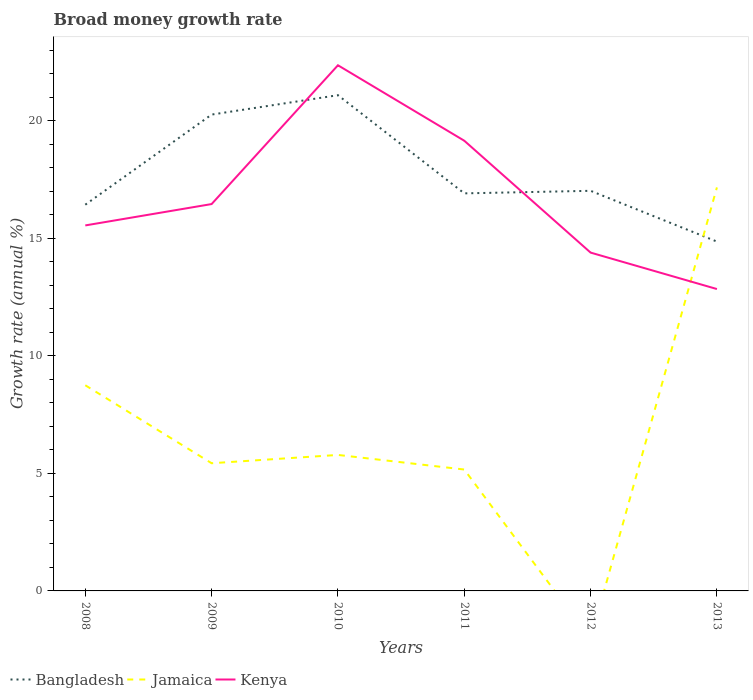Does the line corresponding to Kenya intersect with the line corresponding to Jamaica?
Keep it short and to the point. Yes. Is the number of lines equal to the number of legend labels?
Ensure brevity in your answer.  No. Across all years, what is the maximum growth rate in Bangladesh?
Make the answer very short. 14.86. What is the total growth rate in Kenya in the graph?
Keep it short and to the point. 6.31. What is the difference between the highest and the second highest growth rate in Jamaica?
Give a very brief answer. 17.17. What is the difference between the highest and the lowest growth rate in Kenya?
Provide a short and direct response. 2. Is the growth rate in Kenya strictly greater than the growth rate in Jamaica over the years?
Give a very brief answer. No. How many lines are there?
Offer a very short reply. 3. How many years are there in the graph?
Your answer should be very brief. 6. What is the difference between two consecutive major ticks on the Y-axis?
Your answer should be compact. 5. Does the graph contain grids?
Keep it short and to the point. No. How many legend labels are there?
Ensure brevity in your answer.  3. How are the legend labels stacked?
Offer a terse response. Horizontal. What is the title of the graph?
Offer a terse response. Broad money growth rate. What is the label or title of the X-axis?
Offer a terse response. Years. What is the label or title of the Y-axis?
Provide a short and direct response. Growth rate (annual %). What is the Growth rate (annual %) in Bangladesh in 2008?
Provide a short and direct response. 16.43. What is the Growth rate (annual %) of Jamaica in 2008?
Offer a very short reply. 8.75. What is the Growth rate (annual %) in Kenya in 2008?
Make the answer very short. 15.55. What is the Growth rate (annual %) of Bangladesh in 2009?
Ensure brevity in your answer.  20.26. What is the Growth rate (annual %) of Jamaica in 2009?
Your answer should be very brief. 5.43. What is the Growth rate (annual %) in Kenya in 2009?
Ensure brevity in your answer.  16.46. What is the Growth rate (annual %) in Bangladesh in 2010?
Offer a terse response. 21.09. What is the Growth rate (annual %) in Jamaica in 2010?
Offer a terse response. 5.79. What is the Growth rate (annual %) of Kenya in 2010?
Make the answer very short. 22.36. What is the Growth rate (annual %) in Bangladesh in 2011?
Your answer should be compact. 16.91. What is the Growth rate (annual %) of Jamaica in 2011?
Keep it short and to the point. 5.16. What is the Growth rate (annual %) in Kenya in 2011?
Offer a very short reply. 19.15. What is the Growth rate (annual %) in Bangladesh in 2012?
Offer a terse response. 17.02. What is the Growth rate (annual %) in Kenya in 2012?
Give a very brief answer. 14.39. What is the Growth rate (annual %) of Bangladesh in 2013?
Ensure brevity in your answer.  14.86. What is the Growth rate (annual %) of Jamaica in 2013?
Offer a terse response. 17.17. What is the Growth rate (annual %) in Kenya in 2013?
Your response must be concise. 12.84. Across all years, what is the maximum Growth rate (annual %) in Bangladesh?
Ensure brevity in your answer.  21.09. Across all years, what is the maximum Growth rate (annual %) of Jamaica?
Offer a very short reply. 17.17. Across all years, what is the maximum Growth rate (annual %) in Kenya?
Ensure brevity in your answer.  22.36. Across all years, what is the minimum Growth rate (annual %) of Bangladesh?
Provide a succinct answer. 14.86. Across all years, what is the minimum Growth rate (annual %) of Kenya?
Ensure brevity in your answer.  12.84. What is the total Growth rate (annual %) in Bangladesh in the graph?
Make the answer very short. 106.58. What is the total Growth rate (annual %) in Jamaica in the graph?
Your answer should be compact. 42.3. What is the total Growth rate (annual %) in Kenya in the graph?
Provide a succinct answer. 100.75. What is the difference between the Growth rate (annual %) of Bangladesh in 2008 and that in 2009?
Keep it short and to the point. -3.83. What is the difference between the Growth rate (annual %) of Jamaica in 2008 and that in 2009?
Your answer should be compact. 3.32. What is the difference between the Growth rate (annual %) in Kenya in 2008 and that in 2009?
Your response must be concise. -0.91. What is the difference between the Growth rate (annual %) in Bangladesh in 2008 and that in 2010?
Give a very brief answer. -4.66. What is the difference between the Growth rate (annual %) of Jamaica in 2008 and that in 2010?
Provide a short and direct response. 2.96. What is the difference between the Growth rate (annual %) in Kenya in 2008 and that in 2010?
Keep it short and to the point. -6.81. What is the difference between the Growth rate (annual %) in Bangladesh in 2008 and that in 2011?
Provide a succinct answer. -0.48. What is the difference between the Growth rate (annual %) in Jamaica in 2008 and that in 2011?
Ensure brevity in your answer.  3.58. What is the difference between the Growth rate (annual %) of Kenya in 2008 and that in 2011?
Your answer should be compact. -3.6. What is the difference between the Growth rate (annual %) of Bangladesh in 2008 and that in 2012?
Give a very brief answer. -0.59. What is the difference between the Growth rate (annual %) of Kenya in 2008 and that in 2012?
Your answer should be very brief. 1.16. What is the difference between the Growth rate (annual %) in Bangladesh in 2008 and that in 2013?
Provide a short and direct response. 1.57. What is the difference between the Growth rate (annual %) in Jamaica in 2008 and that in 2013?
Your answer should be compact. -8.42. What is the difference between the Growth rate (annual %) of Kenya in 2008 and that in 2013?
Provide a succinct answer. 2.71. What is the difference between the Growth rate (annual %) in Bangladesh in 2009 and that in 2010?
Your response must be concise. -0.82. What is the difference between the Growth rate (annual %) of Jamaica in 2009 and that in 2010?
Ensure brevity in your answer.  -0.35. What is the difference between the Growth rate (annual %) in Kenya in 2009 and that in 2010?
Ensure brevity in your answer.  -5.9. What is the difference between the Growth rate (annual %) in Bangladesh in 2009 and that in 2011?
Make the answer very short. 3.35. What is the difference between the Growth rate (annual %) in Jamaica in 2009 and that in 2011?
Keep it short and to the point. 0.27. What is the difference between the Growth rate (annual %) in Kenya in 2009 and that in 2011?
Make the answer very short. -2.69. What is the difference between the Growth rate (annual %) in Bangladesh in 2009 and that in 2012?
Your answer should be compact. 3.24. What is the difference between the Growth rate (annual %) in Kenya in 2009 and that in 2012?
Make the answer very short. 2.06. What is the difference between the Growth rate (annual %) of Bangladesh in 2009 and that in 2013?
Give a very brief answer. 5.4. What is the difference between the Growth rate (annual %) of Jamaica in 2009 and that in 2013?
Provide a short and direct response. -11.73. What is the difference between the Growth rate (annual %) in Kenya in 2009 and that in 2013?
Keep it short and to the point. 3.62. What is the difference between the Growth rate (annual %) in Bangladesh in 2010 and that in 2011?
Keep it short and to the point. 4.18. What is the difference between the Growth rate (annual %) of Jamaica in 2010 and that in 2011?
Give a very brief answer. 0.62. What is the difference between the Growth rate (annual %) of Kenya in 2010 and that in 2011?
Make the answer very short. 3.21. What is the difference between the Growth rate (annual %) in Bangladesh in 2010 and that in 2012?
Provide a short and direct response. 4.07. What is the difference between the Growth rate (annual %) in Kenya in 2010 and that in 2012?
Offer a terse response. 7.97. What is the difference between the Growth rate (annual %) of Bangladesh in 2010 and that in 2013?
Your response must be concise. 6.23. What is the difference between the Growth rate (annual %) in Jamaica in 2010 and that in 2013?
Ensure brevity in your answer.  -11.38. What is the difference between the Growth rate (annual %) in Kenya in 2010 and that in 2013?
Ensure brevity in your answer.  9.52. What is the difference between the Growth rate (annual %) of Bangladesh in 2011 and that in 2012?
Offer a very short reply. -0.11. What is the difference between the Growth rate (annual %) in Kenya in 2011 and that in 2012?
Keep it short and to the point. 4.76. What is the difference between the Growth rate (annual %) in Bangladesh in 2011 and that in 2013?
Make the answer very short. 2.05. What is the difference between the Growth rate (annual %) in Jamaica in 2011 and that in 2013?
Give a very brief answer. -12. What is the difference between the Growth rate (annual %) in Kenya in 2011 and that in 2013?
Make the answer very short. 6.31. What is the difference between the Growth rate (annual %) of Bangladesh in 2012 and that in 2013?
Ensure brevity in your answer.  2.16. What is the difference between the Growth rate (annual %) in Kenya in 2012 and that in 2013?
Keep it short and to the point. 1.55. What is the difference between the Growth rate (annual %) in Bangladesh in 2008 and the Growth rate (annual %) in Jamaica in 2009?
Keep it short and to the point. 11. What is the difference between the Growth rate (annual %) in Bangladesh in 2008 and the Growth rate (annual %) in Kenya in 2009?
Your answer should be compact. -0.03. What is the difference between the Growth rate (annual %) of Jamaica in 2008 and the Growth rate (annual %) of Kenya in 2009?
Ensure brevity in your answer.  -7.71. What is the difference between the Growth rate (annual %) of Bangladesh in 2008 and the Growth rate (annual %) of Jamaica in 2010?
Ensure brevity in your answer.  10.65. What is the difference between the Growth rate (annual %) in Bangladesh in 2008 and the Growth rate (annual %) in Kenya in 2010?
Ensure brevity in your answer.  -5.93. What is the difference between the Growth rate (annual %) of Jamaica in 2008 and the Growth rate (annual %) of Kenya in 2010?
Offer a terse response. -13.61. What is the difference between the Growth rate (annual %) in Bangladesh in 2008 and the Growth rate (annual %) in Jamaica in 2011?
Your answer should be compact. 11.27. What is the difference between the Growth rate (annual %) in Bangladesh in 2008 and the Growth rate (annual %) in Kenya in 2011?
Your answer should be very brief. -2.72. What is the difference between the Growth rate (annual %) in Jamaica in 2008 and the Growth rate (annual %) in Kenya in 2011?
Your response must be concise. -10.4. What is the difference between the Growth rate (annual %) of Bangladesh in 2008 and the Growth rate (annual %) of Kenya in 2012?
Offer a very short reply. 2.04. What is the difference between the Growth rate (annual %) of Jamaica in 2008 and the Growth rate (annual %) of Kenya in 2012?
Your answer should be compact. -5.64. What is the difference between the Growth rate (annual %) of Bangladesh in 2008 and the Growth rate (annual %) of Jamaica in 2013?
Provide a succinct answer. -0.73. What is the difference between the Growth rate (annual %) in Bangladesh in 2008 and the Growth rate (annual %) in Kenya in 2013?
Your answer should be compact. 3.59. What is the difference between the Growth rate (annual %) in Jamaica in 2008 and the Growth rate (annual %) in Kenya in 2013?
Make the answer very short. -4.09. What is the difference between the Growth rate (annual %) in Bangladesh in 2009 and the Growth rate (annual %) in Jamaica in 2010?
Your response must be concise. 14.48. What is the difference between the Growth rate (annual %) in Bangladesh in 2009 and the Growth rate (annual %) in Kenya in 2010?
Your answer should be very brief. -2.1. What is the difference between the Growth rate (annual %) of Jamaica in 2009 and the Growth rate (annual %) of Kenya in 2010?
Offer a very short reply. -16.93. What is the difference between the Growth rate (annual %) in Bangladesh in 2009 and the Growth rate (annual %) in Jamaica in 2011?
Make the answer very short. 15.1. What is the difference between the Growth rate (annual %) of Bangladesh in 2009 and the Growth rate (annual %) of Kenya in 2011?
Ensure brevity in your answer.  1.11. What is the difference between the Growth rate (annual %) in Jamaica in 2009 and the Growth rate (annual %) in Kenya in 2011?
Provide a succinct answer. -13.72. What is the difference between the Growth rate (annual %) of Bangladesh in 2009 and the Growth rate (annual %) of Kenya in 2012?
Give a very brief answer. 5.87. What is the difference between the Growth rate (annual %) of Jamaica in 2009 and the Growth rate (annual %) of Kenya in 2012?
Give a very brief answer. -8.96. What is the difference between the Growth rate (annual %) in Bangladesh in 2009 and the Growth rate (annual %) in Jamaica in 2013?
Provide a short and direct response. 3.1. What is the difference between the Growth rate (annual %) in Bangladesh in 2009 and the Growth rate (annual %) in Kenya in 2013?
Ensure brevity in your answer.  7.42. What is the difference between the Growth rate (annual %) of Jamaica in 2009 and the Growth rate (annual %) of Kenya in 2013?
Give a very brief answer. -7.41. What is the difference between the Growth rate (annual %) of Bangladesh in 2010 and the Growth rate (annual %) of Jamaica in 2011?
Your answer should be very brief. 15.92. What is the difference between the Growth rate (annual %) in Bangladesh in 2010 and the Growth rate (annual %) in Kenya in 2011?
Provide a succinct answer. 1.94. What is the difference between the Growth rate (annual %) of Jamaica in 2010 and the Growth rate (annual %) of Kenya in 2011?
Your answer should be compact. -13.37. What is the difference between the Growth rate (annual %) in Bangladesh in 2010 and the Growth rate (annual %) in Kenya in 2012?
Offer a very short reply. 6.7. What is the difference between the Growth rate (annual %) in Jamaica in 2010 and the Growth rate (annual %) in Kenya in 2012?
Offer a very short reply. -8.61. What is the difference between the Growth rate (annual %) in Bangladesh in 2010 and the Growth rate (annual %) in Jamaica in 2013?
Provide a short and direct response. 3.92. What is the difference between the Growth rate (annual %) of Bangladesh in 2010 and the Growth rate (annual %) of Kenya in 2013?
Make the answer very short. 8.25. What is the difference between the Growth rate (annual %) of Jamaica in 2010 and the Growth rate (annual %) of Kenya in 2013?
Your answer should be compact. -7.06. What is the difference between the Growth rate (annual %) in Bangladesh in 2011 and the Growth rate (annual %) in Kenya in 2012?
Your answer should be compact. 2.52. What is the difference between the Growth rate (annual %) of Jamaica in 2011 and the Growth rate (annual %) of Kenya in 2012?
Ensure brevity in your answer.  -9.23. What is the difference between the Growth rate (annual %) in Bangladesh in 2011 and the Growth rate (annual %) in Jamaica in 2013?
Keep it short and to the point. -0.25. What is the difference between the Growth rate (annual %) of Bangladesh in 2011 and the Growth rate (annual %) of Kenya in 2013?
Offer a terse response. 4.07. What is the difference between the Growth rate (annual %) of Jamaica in 2011 and the Growth rate (annual %) of Kenya in 2013?
Your answer should be compact. -7.68. What is the difference between the Growth rate (annual %) in Bangladesh in 2012 and the Growth rate (annual %) in Jamaica in 2013?
Your answer should be compact. -0.14. What is the difference between the Growth rate (annual %) of Bangladesh in 2012 and the Growth rate (annual %) of Kenya in 2013?
Offer a terse response. 4.18. What is the average Growth rate (annual %) of Bangladesh per year?
Offer a terse response. 17.76. What is the average Growth rate (annual %) in Jamaica per year?
Give a very brief answer. 7.05. What is the average Growth rate (annual %) in Kenya per year?
Give a very brief answer. 16.79. In the year 2008, what is the difference between the Growth rate (annual %) in Bangladesh and Growth rate (annual %) in Jamaica?
Give a very brief answer. 7.68. In the year 2008, what is the difference between the Growth rate (annual %) of Bangladesh and Growth rate (annual %) of Kenya?
Make the answer very short. 0.88. In the year 2008, what is the difference between the Growth rate (annual %) in Jamaica and Growth rate (annual %) in Kenya?
Keep it short and to the point. -6.8. In the year 2009, what is the difference between the Growth rate (annual %) in Bangladesh and Growth rate (annual %) in Jamaica?
Give a very brief answer. 14.83. In the year 2009, what is the difference between the Growth rate (annual %) of Bangladesh and Growth rate (annual %) of Kenya?
Provide a short and direct response. 3.81. In the year 2009, what is the difference between the Growth rate (annual %) of Jamaica and Growth rate (annual %) of Kenya?
Provide a short and direct response. -11.03. In the year 2010, what is the difference between the Growth rate (annual %) of Bangladesh and Growth rate (annual %) of Jamaica?
Offer a very short reply. 15.3. In the year 2010, what is the difference between the Growth rate (annual %) of Bangladesh and Growth rate (annual %) of Kenya?
Make the answer very short. -1.27. In the year 2010, what is the difference between the Growth rate (annual %) in Jamaica and Growth rate (annual %) in Kenya?
Keep it short and to the point. -16.58. In the year 2011, what is the difference between the Growth rate (annual %) in Bangladesh and Growth rate (annual %) in Jamaica?
Offer a terse response. 11.75. In the year 2011, what is the difference between the Growth rate (annual %) of Bangladesh and Growth rate (annual %) of Kenya?
Make the answer very short. -2.24. In the year 2011, what is the difference between the Growth rate (annual %) of Jamaica and Growth rate (annual %) of Kenya?
Your answer should be compact. -13.99. In the year 2012, what is the difference between the Growth rate (annual %) in Bangladesh and Growth rate (annual %) in Kenya?
Give a very brief answer. 2.63. In the year 2013, what is the difference between the Growth rate (annual %) of Bangladesh and Growth rate (annual %) of Jamaica?
Your answer should be compact. -2.3. In the year 2013, what is the difference between the Growth rate (annual %) in Bangladesh and Growth rate (annual %) in Kenya?
Provide a short and direct response. 2.02. In the year 2013, what is the difference between the Growth rate (annual %) in Jamaica and Growth rate (annual %) in Kenya?
Keep it short and to the point. 4.32. What is the ratio of the Growth rate (annual %) in Bangladesh in 2008 to that in 2009?
Provide a succinct answer. 0.81. What is the ratio of the Growth rate (annual %) in Jamaica in 2008 to that in 2009?
Your answer should be compact. 1.61. What is the ratio of the Growth rate (annual %) of Kenya in 2008 to that in 2009?
Your answer should be very brief. 0.94. What is the ratio of the Growth rate (annual %) in Bangladesh in 2008 to that in 2010?
Your response must be concise. 0.78. What is the ratio of the Growth rate (annual %) in Jamaica in 2008 to that in 2010?
Make the answer very short. 1.51. What is the ratio of the Growth rate (annual %) of Kenya in 2008 to that in 2010?
Offer a very short reply. 0.7. What is the ratio of the Growth rate (annual %) in Bangladesh in 2008 to that in 2011?
Make the answer very short. 0.97. What is the ratio of the Growth rate (annual %) in Jamaica in 2008 to that in 2011?
Keep it short and to the point. 1.69. What is the ratio of the Growth rate (annual %) in Kenya in 2008 to that in 2011?
Your answer should be compact. 0.81. What is the ratio of the Growth rate (annual %) of Bangladesh in 2008 to that in 2012?
Offer a terse response. 0.97. What is the ratio of the Growth rate (annual %) in Kenya in 2008 to that in 2012?
Your answer should be very brief. 1.08. What is the ratio of the Growth rate (annual %) of Bangladesh in 2008 to that in 2013?
Provide a succinct answer. 1.11. What is the ratio of the Growth rate (annual %) of Jamaica in 2008 to that in 2013?
Provide a short and direct response. 0.51. What is the ratio of the Growth rate (annual %) of Kenya in 2008 to that in 2013?
Offer a terse response. 1.21. What is the ratio of the Growth rate (annual %) in Bangladesh in 2009 to that in 2010?
Your response must be concise. 0.96. What is the ratio of the Growth rate (annual %) in Jamaica in 2009 to that in 2010?
Your answer should be very brief. 0.94. What is the ratio of the Growth rate (annual %) of Kenya in 2009 to that in 2010?
Ensure brevity in your answer.  0.74. What is the ratio of the Growth rate (annual %) of Bangladesh in 2009 to that in 2011?
Your answer should be very brief. 1.2. What is the ratio of the Growth rate (annual %) of Jamaica in 2009 to that in 2011?
Offer a terse response. 1.05. What is the ratio of the Growth rate (annual %) of Kenya in 2009 to that in 2011?
Give a very brief answer. 0.86. What is the ratio of the Growth rate (annual %) in Bangladesh in 2009 to that in 2012?
Ensure brevity in your answer.  1.19. What is the ratio of the Growth rate (annual %) in Kenya in 2009 to that in 2012?
Your response must be concise. 1.14. What is the ratio of the Growth rate (annual %) in Bangladesh in 2009 to that in 2013?
Your answer should be compact. 1.36. What is the ratio of the Growth rate (annual %) of Jamaica in 2009 to that in 2013?
Provide a succinct answer. 0.32. What is the ratio of the Growth rate (annual %) in Kenya in 2009 to that in 2013?
Your response must be concise. 1.28. What is the ratio of the Growth rate (annual %) of Bangladesh in 2010 to that in 2011?
Offer a very short reply. 1.25. What is the ratio of the Growth rate (annual %) of Jamaica in 2010 to that in 2011?
Your answer should be very brief. 1.12. What is the ratio of the Growth rate (annual %) of Kenya in 2010 to that in 2011?
Your answer should be very brief. 1.17. What is the ratio of the Growth rate (annual %) in Bangladesh in 2010 to that in 2012?
Give a very brief answer. 1.24. What is the ratio of the Growth rate (annual %) of Kenya in 2010 to that in 2012?
Offer a terse response. 1.55. What is the ratio of the Growth rate (annual %) in Bangladesh in 2010 to that in 2013?
Ensure brevity in your answer.  1.42. What is the ratio of the Growth rate (annual %) in Jamaica in 2010 to that in 2013?
Your answer should be compact. 0.34. What is the ratio of the Growth rate (annual %) in Kenya in 2010 to that in 2013?
Your answer should be very brief. 1.74. What is the ratio of the Growth rate (annual %) in Kenya in 2011 to that in 2012?
Offer a terse response. 1.33. What is the ratio of the Growth rate (annual %) in Bangladesh in 2011 to that in 2013?
Give a very brief answer. 1.14. What is the ratio of the Growth rate (annual %) of Jamaica in 2011 to that in 2013?
Your response must be concise. 0.3. What is the ratio of the Growth rate (annual %) of Kenya in 2011 to that in 2013?
Your answer should be compact. 1.49. What is the ratio of the Growth rate (annual %) of Bangladesh in 2012 to that in 2013?
Ensure brevity in your answer.  1.15. What is the ratio of the Growth rate (annual %) in Kenya in 2012 to that in 2013?
Provide a succinct answer. 1.12. What is the difference between the highest and the second highest Growth rate (annual %) in Bangladesh?
Your response must be concise. 0.82. What is the difference between the highest and the second highest Growth rate (annual %) of Jamaica?
Give a very brief answer. 8.42. What is the difference between the highest and the second highest Growth rate (annual %) of Kenya?
Give a very brief answer. 3.21. What is the difference between the highest and the lowest Growth rate (annual %) in Bangladesh?
Your answer should be compact. 6.23. What is the difference between the highest and the lowest Growth rate (annual %) in Jamaica?
Offer a very short reply. 17.17. What is the difference between the highest and the lowest Growth rate (annual %) in Kenya?
Provide a succinct answer. 9.52. 